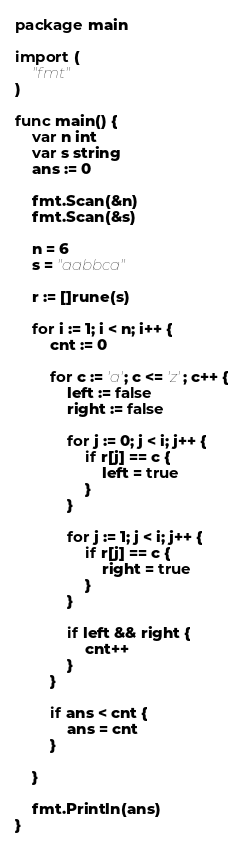<code> <loc_0><loc_0><loc_500><loc_500><_Go_>package main

import (
	"fmt"
)

func main() {
	var n int
	var s string
	ans := 0

	fmt.Scan(&n)
	fmt.Scan(&s)

	n = 6
	s = "aabbca"

	r := []rune(s)

	for i := 1; i < n; i++ {
		cnt := 0

		for c := 'a'; c <= 'z'; c++ {
			left := false
			right := false

			for j := 0; j < i; j++ {
				if r[j] == c {
					left = true
				}
			}

			for j := 1; j < i; j++ {
				if r[j] == c {
					right = true
				}
			}

			if left && right {
				cnt++
			}
		}
		
		if ans < cnt {
			ans = cnt
		}
		
	}
	
	fmt.Println(ans)
}
</code> 